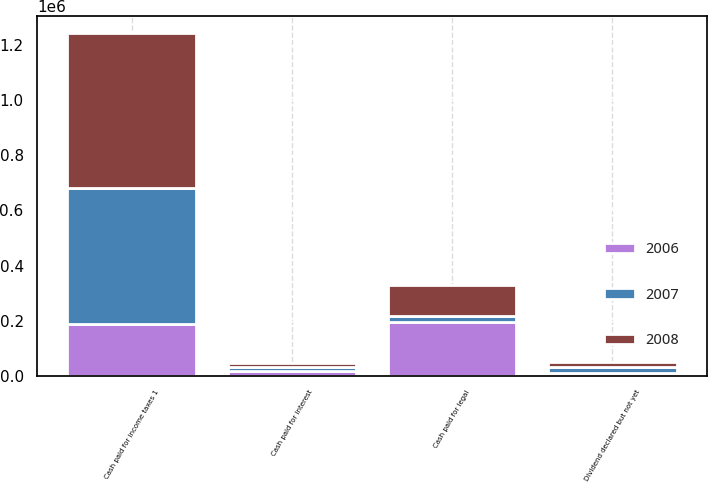Convert chart. <chart><loc_0><loc_0><loc_500><loc_500><stacked_bar_chart><ecel><fcel>Cash paid for income taxes 1<fcel>Cash paid for interest<fcel>Cash paid for legal<fcel>Dividend declared but not yet<nl><fcel>2007<fcel>493199<fcel>14058<fcel>19969<fcel>19690<nl><fcel>2008<fcel>561860<fcel>17094<fcel>113925<fcel>19969<nl><fcel>2006<fcel>186961<fcel>17034<fcel>195840<fcel>12402<nl></chart> 